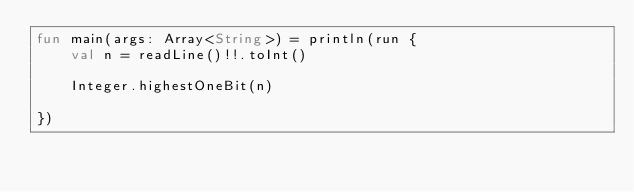<code> <loc_0><loc_0><loc_500><loc_500><_Kotlin_>fun main(args: Array<String>) = println(run {
    val n = readLine()!!.toInt()

    Integer.highestOneBit(n)

})
</code> 